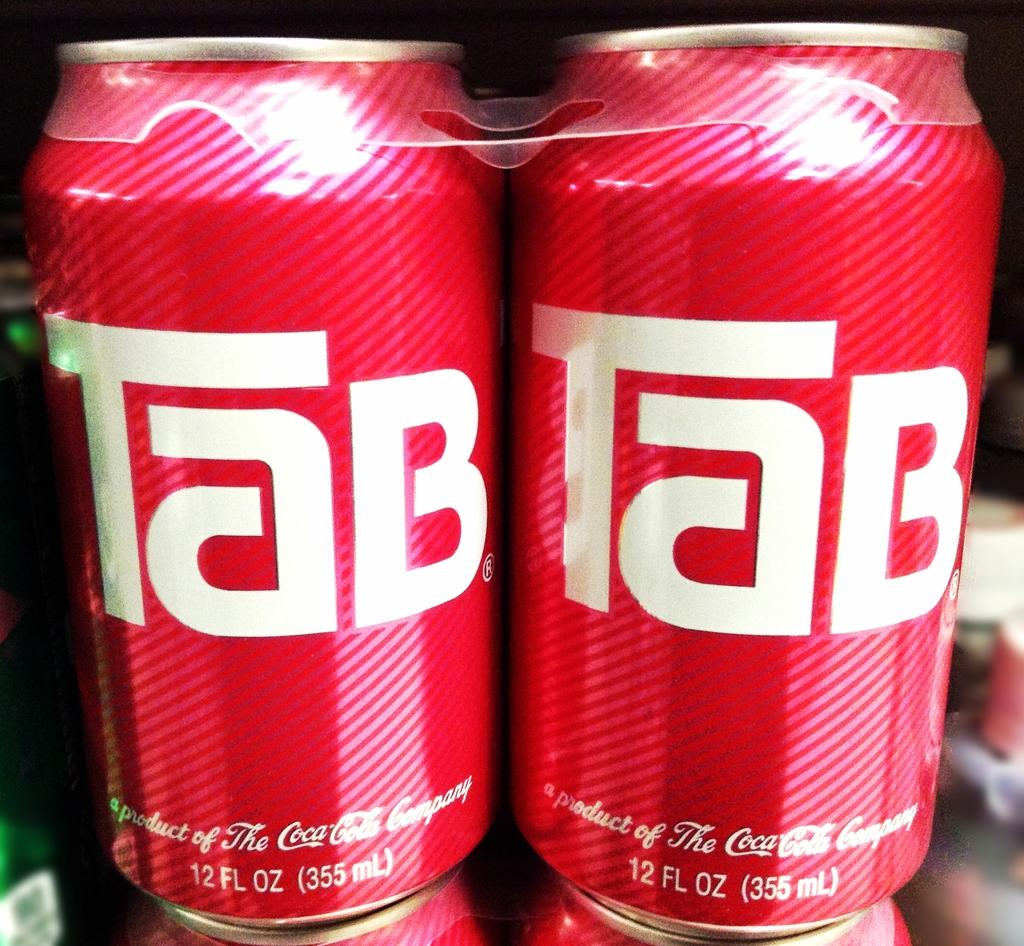<image>
Summarize the visual content of the image. Two red cans of the brand Tab are stacked on top of other cans. 